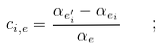<formula> <loc_0><loc_0><loc_500><loc_500>c _ { i , e } = \frac { \alpha _ { e _ { i } ^ { \prime } } - \alpha _ { e _ { i } } } { \alpha _ { e } } \quad ;</formula> 